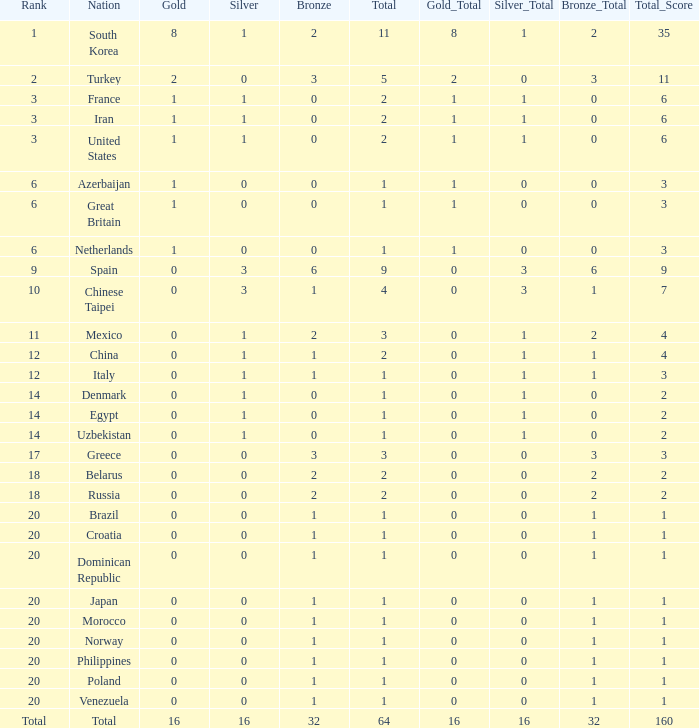What is the average number of bronze of the nation with more than 1 gold and 1 silver medal? 2.0. 